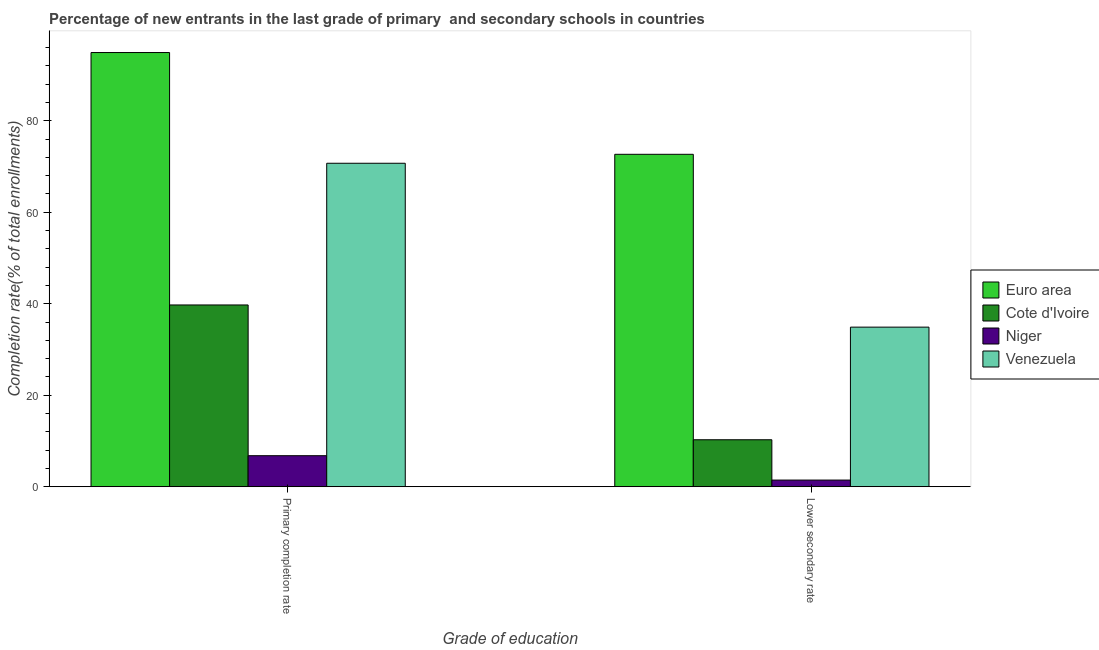Are the number of bars per tick equal to the number of legend labels?
Provide a short and direct response. Yes. How many bars are there on the 2nd tick from the left?
Provide a succinct answer. 4. What is the label of the 2nd group of bars from the left?
Your answer should be very brief. Lower secondary rate. What is the completion rate in secondary schools in Niger?
Keep it short and to the point. 1.45. Across all countries, what is the maximum completion rate in secondary schools?
Provide a succinct answer. 72.67. Across all countries, what is the minimum completion rate in primary schools?
Keep it short and to the point. 6.78. In which country was the completion rate in secondary schools maximum?
Offer a very short reply. Euro area. In which country was the completion rate in primary schools minimum?
Make the answer very short. Niger. What is the total completion rate in primary schools in the graph?
Your response must be concise. 212.14. What is the difference between the completion rate in secondary schools in Euro area and that in Niger?
Provide a short and direct response. 71.22. What is the difference between the completion rate in primary schools in Cote d'Ivoire and the completion rate in secondary schools in Venezuela?
Offer a terse response. 4.85. What is the average completion rate in primary schools per country?
Provide a short and direct response. 53.04. What is the difference between the completion rate in primary schools and completion rate in secondary schools in Euro area?
Make the answer very short. 22.25. In how many countries, is the completion rate in primary schools greater than 60 %?
Your response must be concise. 2. What is the ratio of the completion rate in secondary schools in Niger to that in Euro area?
Your answer should be very brief. 0.02. Is the completion rate in primary schools in Venezuela less than that in Cote d'Ivoire?
Your answer should be compact. No. In how many countries, is the completion rate in primary schools greater than the average completion rate in primary schools taken over all countries?
Keep it short and to the point. 2. What does the 2nd bar from the left in Primary completion rate represents?
Provide a succinct answer. Cote d'Ivoire. What does the 1st bar from the right in Lower secondary rate represents?
Give a very brief answer. Venezuela. Are all the bars in the graph horizontal?
Give a very brief answer. No. How many countries are there in the graph?
Provide a short and direct response. 4. Are the values on the major ticks of Y-axis written in scientific E-notation?
Offer a very short reply. No. Does the graph contain any zero values?
Provide a short and direct response. No. Does the graph contain grids?
Ensure brevity in your answer.  No. How many legend labels are there?
Your answer should be compact. 4. How are the legend labels stacked?
Your response must be concise. Vertical. What is the title of the graph?
Provide a succinct answer. Percentage of new entrants in the last grade of primary  and secondary schools in countries. Does "High income" appear as one of the legend labels in the graph?
Your answer should be compact. No. What is the label or title of the X-axis?
Your answer should be very brief. Grade of education. What is the label or title of the Y-axis?
Make the answer very short. Completion rate(% of total enrollments). What is the Completion rate(% of total enrollments) in Euro area in Primary completion rate?
Provide a succinct answer. 94.92. What is the Completion rate(% of total enrollments) of Cote d'Ivoire in Primary completion rate?
Make the answer very short. 39.74. What is the Completion rate(% of total enrollments) in Niger in Primary completion rate?
Give a very brief answer. 6.78. What is the Completion rate(% of total enrollments) of Venezuela in Primary completion rate?
Offer a terse response. 70.71. What is the Completion rate(% of total enrollments) of Euro area in Lower secondary rate?
Provide a short and direct response. 72.67. What is the Completion rate(% of total enrollments) of Cote d'Ivoire in Lower secondary rate?
Ensure brevity in your answer.  10.27. What is the Completion rate(% of total enrollments) of Niger in Lower secondary rate?
Ensure brevity in your answer.  1.45. What is the Completion rate(% of total enrollments) in Venezuela in Lower secondary rate?
Give a very brief answer. 34.89. Across all Grade of education, what is the maximum Completion rate(% of total enrollments) in Euro area?
Provide a short and direct response. 94.92. Across all Grade of education, what is the maximum Completion rate(% of total enrollments) in Cote d'Ivoire?
Your answer should be compact. 39.74. Across all Grade of education, what is the maximum Completion rate(% of total enrollments) in Niger?
Offer a very short reply. 6.78. Across all Grade of education, what is the maximum Completion rate(% of total enrollments) of Venezuela?
Your response must be concise. 70.71. Across all Grade of education, what is the minimum Completion rate(% of total enrollments) of Euro area?
Keep it short and to the point. 72.67. Across all Grade of education, what is the minimum Completion rate(% of total enrollments) of Cote d'Ivoire?
Provide a short and direct response. 10.27. Across all Grade of education, what is the minimum Completion rate(% of total enrollments) in Niger?
Provide a succinct answer. 1.45. Across all Grade of education, what is the minimum Completion rate(% of total enrollments) of Venezuela?
Provide a short and direct response. 34.89. What is the total Completion rate(% of total enrollments) of Euro area in the graph?
Your answer should be compact. 167.59. What is the total Completion rate(% of total enrollments) of Cote d'Ivoire in the graph?
Offer a very short reply. 50. What is the total Completion rate(% of total enrollments) of Niger in the graph?
Make the answer very short. 8.24. What is the total Completion rate(% of total enrollments) of Venezuela in the graph?
Offer a terse response. 105.6. What is the difference between the Completion rate(% of total enrollments) in Euro area in Primary completion rate and that in Lower secondary rate?
Give a very brief answer. 22.25. What is the difference between the Completion rate(% of total enrollments) in Cote d'Ivoire in Primary completion rate and that in Lower secondary rate?
Keep it short and to the point. 29.47. What is the difference between the Completion rate(% of total enrollments) in Niger in Primary completion rate and that in Lower secondary rate?
Your answer should be very brief. 5.33. What is the difference between the Completion rate(% of total enrollments) of Venezuela in Primary completion rate and that in Lower secondary rate?
Provide a short and direct response. 35.82. What is the difference between the Completion rate(% of total enrollments) in Euro area in Primary completion rate and the Completion rate(% of total enrollments) in Cote d'Ivoire in Lower secondary rate?
Give a very brief answer. 84.65. What is the difference between the Completion rate(% of total enrollments) in Euro area in Primary completion rate and the Completion rate(% of total enrollments) in Niger in Lower secondary rate?
Provide a succinct answer. 93.46. What is the difference between the Completion rate(% of total enrollments) in Euro area in Primary completion rate and the Completion rate(% of total enrollments) in Venezuela in Lower secondary rate?
Give a very brief answer. 60.03. What is the difference between the Completion rate(% of total enrollments) in Cote d'Ivoire in Primary completion rate and the Completion rate(% of total enrollments) in Niger in Lower secondary rate?
Offer a terse response. 38.28. What is the difference between the Completion rate(% of total enrollments) of Cote d'Ivoire in Primary completion rate and the Completion rate(% of total enrollments) of Venezuela in Lower secondary rate?
Your response must be concise. 4.85. What is the difference between the Completion rate(% of total enrollments) in Niger in Primary completion rate and the Completion rate(% of total enrollments) in Venezuela in Lower secondary rate?
Your answer should be compact. -28.11. What is the average Completion rate(% of total enrollments) of Euro area per Grade of education?
Make the answer very short. 83.79. What is the average Completion rate(% of total enrollments) in Cote d'Ivoire per Grade of education?
Offer a terse response. 25. What is the average Completion rate(% of total enrollments) in Niger per Grade of education?
Provide a succinct answer. 4.12. What is the average Completion rate(% of total enrollments) of Venezuela per Grade of education?
Give a very brief answer. 52.8. What is the difference between the Completion rate(% of total enrollments) of Euro area and Completion rate(% of total enrollments) of Cote d'Ivoire in Primary completion rate?
Ensure brevity in your answer.  55.18. What is the difference between the Completion rate(% of total enrollments) of Euro area and Completion rate(% of total enrollments) of Niger in Primary completion rate?
Ensure brevity in your answer.  88.13. What is the difference between the Completion rate(% of total enrollments) in Euro area and Completion rate(% of total enrollments) in Venezuela in Primary completion rate?
Your response must be concise. 24.21. What is the difference between the Completion rate(% of total enrollments) in Cote d'Ivoire and Completion rate(% of total enrollments) in Niger in Primary completion rate?
Your answer should be compact. 32.95. What is the difference between the Completion rate(% of total enrollments) of Cote d'Ivoire and Completion rate(% of total enrollments) of Venezuela in Primary completion rate?
Provide a short and direct response. -30.98. What is the difference between the Completion rate(% of total enrollments) in Niger and Completion rate(% of total enrollments) in Venezuela in Primary completion rate?
Give a very brief answer. -63.93. What is the difference between the Completion rate(% of total enrollments) of Euro area and Completion rate(% of total enrollments) of Cote d'Ivoire in Lower secondary rate?
Your answer should be very brief. 62.4. What is the difference between the Completion rate(% of total enrollments) in Euro area and Completion rate(% of total enrollments) in Niger in Lower secondary rate?
Offer a terse response. 71.22. What is the difference between the Completion rate(% of total enrollments) of Euro area and Completion rate(% of total enrollments) of Venezuela in Lower secondary rate?
Offer a very short reply. 37.78. What is the difference between the Completion rate(% of total enrollments) in Cote d'Ivoire and Completion rate(% of total enrollments) in Niger in Lower secondary rate?
Ensure brevity in your answer.  8.82. What is the difference between the Completion rate(% of total enrollments) in Cote d'Ivoire and Completion rate(% of total enrollments) in Venezuela in Lower secondary rate?
Ensure brevity in your answer.  -24.62. What is the difference between the Completion rate(% of total enrollments) in Niger and Completion rate(% of total enrollments) in Venezuela in Lower secondary rate?
Give a very brief answer. -33.43. What is the ratio of the Completion rate(% of total enrollments) of Euro area in Primary completion rate to that in Lower secondary rate?
Ensure brevity in your answer.  1.31. What is the ratio of the Completion rate(% of total enrollments) of Cote d'Ivoire in Primary completion rate to that in Lower secondary rate?
Make the answer very short. 3.87. What is the ratio of the Completion rate(% of total enrollments) of Niger in Primary completion rate to that in Lower secondary rate?
Offer a very short reply. 4.67. What is the ratio of the Completion rate(% of total enrollments) in Venezuela in Primary completion rate to that in Lower secondary rate?
Your answer should be very brief. 2.03. What is the difference between the highest and the second highest Completion rate(% of total enrollments) in Euro area?
Offer a terse response. 22.25. What is the difference between the highest and the second highest Completion rate(% of total enrollments) of Cote d'Ivoire?
Provide a short and direct response. 29.47. What is the difference between the highest and the second highest Completion rate(% of total enrollments) in Niger?
Your answer should be compact. 5.33. What is the difference between the highest and the second highest Completion rate(% of total enrollments) in Venezuela?
Provide a short and direct response. 35.82. What is the difference between the highest and the lowest Completion rate(% of total enrollments) of Euro area?
Offer a very short reply. 22.25. What is the difference between the highest and the lowest Completion rate(% of total enrollments) in Cote d'Ivoire?
Offer a terse response. 29.47. What is the difference between the highest and the lowest Completion rate(% of total enrollments) in Niger?
Provide a succinct answer. 5.33. What is the difference between the highest and the lowest Completion rate(% of total enrollments) of Venezuela?
Your answer should be very brief. 35.82. 